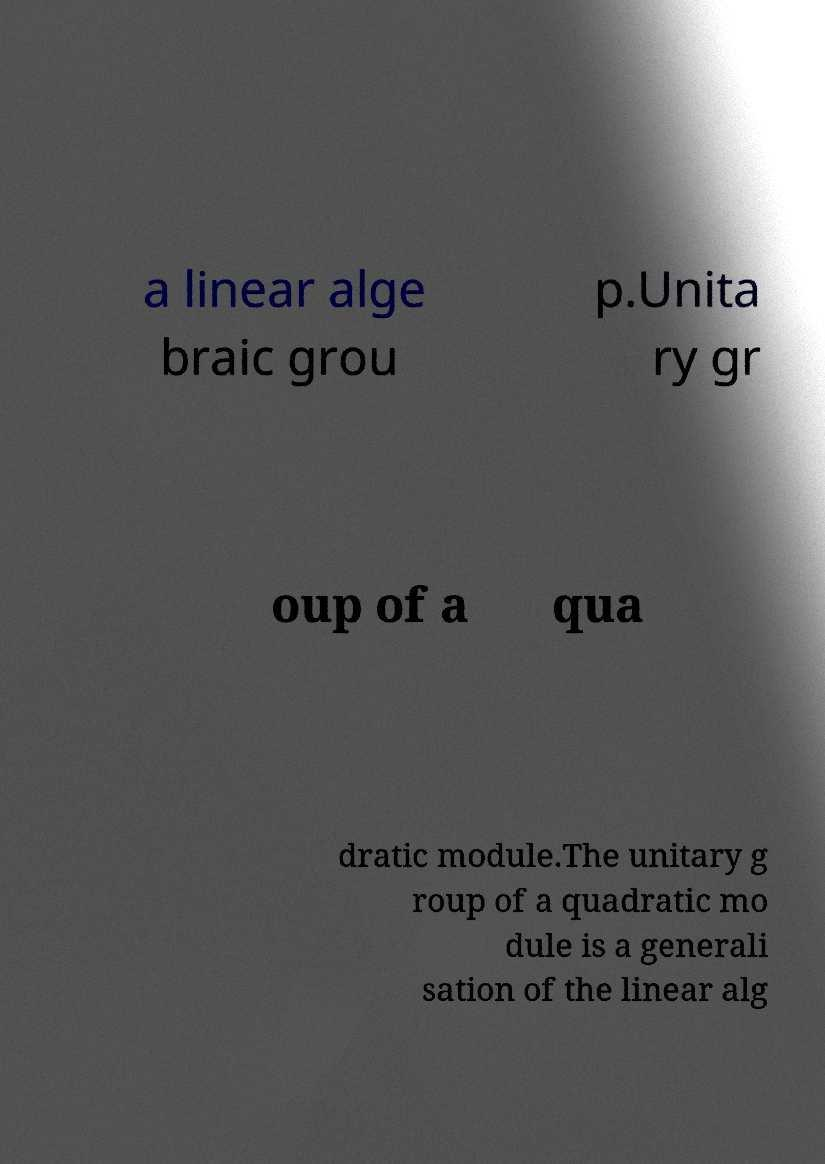For documentation purposes, I need the text within this image transcribed. Could you provide that? a linear alge braic grou p.Unita ry gr oup of a qua dratic module.The unitary g roup of a quadratic mo dule is a generali sation of the linear alg 